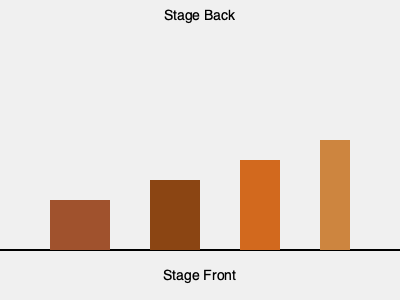As a casting director working on a new production, you need to arrange furniture on a stage to create depth and perspective. Given the diagram of a stage set, which arrangement of furniture pieces (from front to back) would create the most effective illusion of depth? To create the illusion of depth and perspective on a stage, we need to consider the principles of forced perspective. This technique involves manipulating the size and placement of objects to make them appear further away or closer than they actually are. Let's analyze the diagram step-by-step:

1. The stage is represented by the horizontal line at the bottom of the image.
2. There are four furniture pieces shown, each represented by a rectangle.
3. The rectangles decrease in width from left to right, while increasing in height.
4. In stage design, objects that are meant to appear further away should be smaller and placed higher on the stage (closer to the back).

Following these principles:

1. The widest and shortest piece (leftmost) should be placed at the front of the stage.
2. The second widest piece should be placed second.
3. The third widest piece should be placed third.
4. The narrowest and tallest piece (rightmost) should be placed at the back of the stage.

This arrangement will create a gradual decrease in size from front to back, enhancing the illusion of depth and perspective on the stage.
Answer: Widest to narrowest, shortest to tallest 